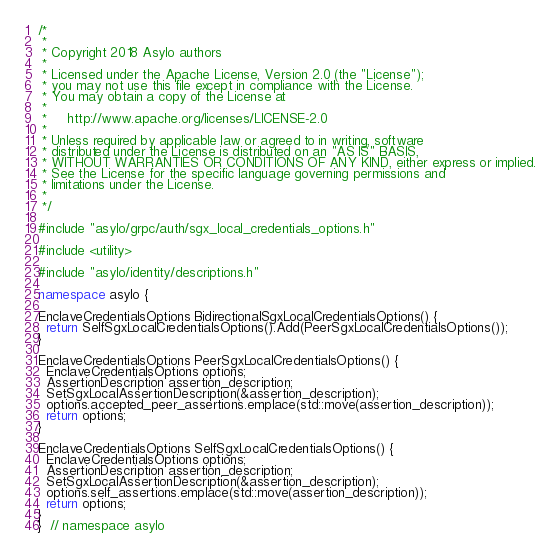Convert code to text. <code><loc_0><loc_0><loc_500><loc_500><_C++_>/*
 *
 * Copyright 2018 Asylo authors
 *
 * Licensed under the Apache License, Version 2.0 (the "License");
 * you may not use this file except in compliance with the License.
 * You may obtain a copy of the License at
 *
 *     http://www.apache.org/licenses/LICENSE-2.0
 *
 * Unless required by applicable law or agreed to in writing, software
 * distributed under the License is distributed on an "AS IS" BASIS,
 * WITHOUT WARRANTIES OR CONDITIONS OF ANY KIND, either express or implied.
 * See the License for the specific language governing permissions and
 * limitations under the License.
 *
 */

#include "asylo/grpc/auth/sgx_local_credentials_options.h"

#include <utility>

#include "asylo/identity/descriptions.h"

namespace asylo {

EnclaveCredentialsOptions BidirectionalSgxLocalCredentialsOptions() {
  return SelfSgxLocalCredentialsOptions().Add(PeerSgxLocalCredentialsOptions());
}

EnclaveCredentialsOptions PeerSgxLocalCredentialsOptions() {
  EnclaveCredentialsOptions options;
  AssertionDescription assertion_description;
  SetSgxLocalAssertionDescription(&assertion_description);
  options.accepted_peer_assertions.emplace(std::move(assertion_description));
  return options;
}

EnclaveCredentialsOptions SelfSgxLocalCredentialsOptions() {
  EnclaveCredentialsOptions options;
  AssertionDescription assertion_description;
  SetSgxLocalAssertionDescription(&assertion_description);
  options.self_assertions.emplace(std::move(assertion_description));
  return options;
}
}  // namespace asylo
</code> 